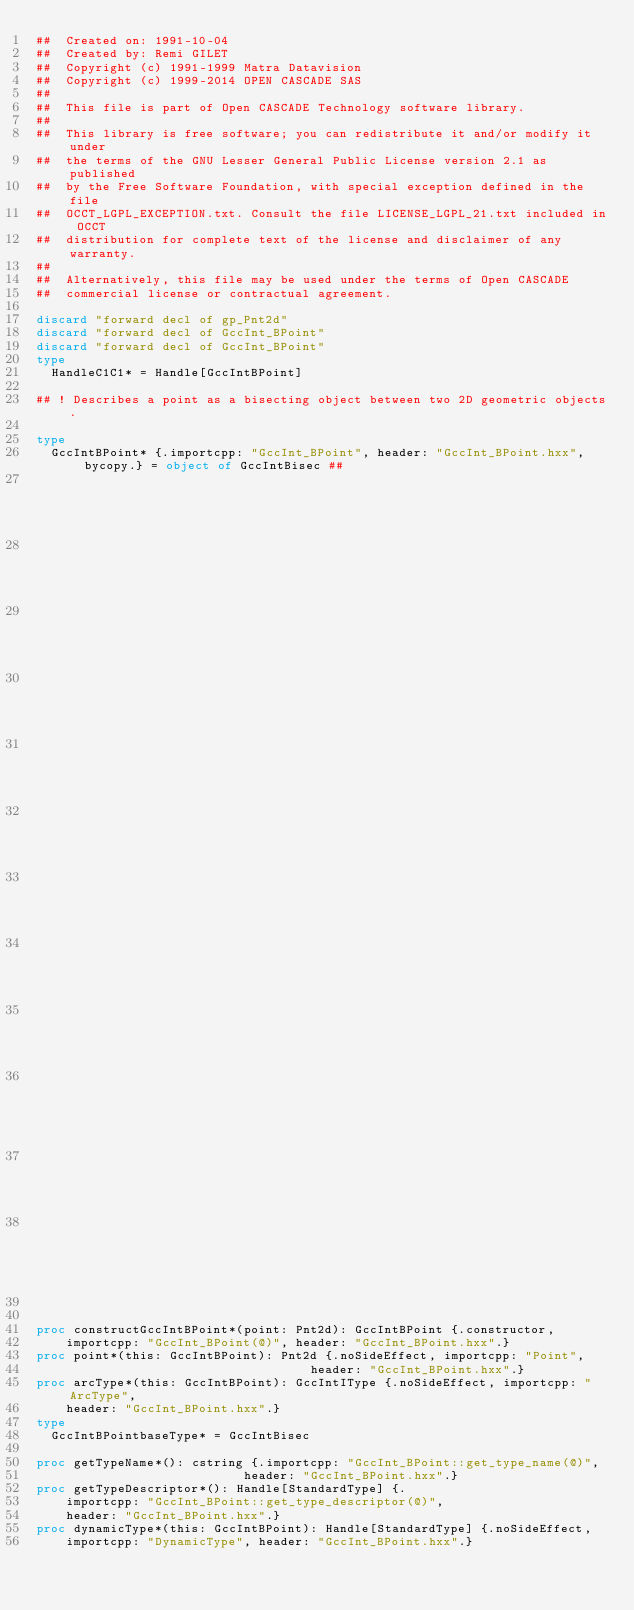Convert code to text. <code><loc_0><loc_0><loc_500><loc_500><_Nim_>##  Created on: 1991-10-04
##  Created by: Remi GILET
##  Copyright (c) 1991-1999 Matra Datavision
##  Copyright (c) 1999-2014 OPEN CASCADE SAS
##
##  This file is part of Open CASCADE Technology software library.
##
##  This library is free software; you can redistribute it and/or modify it under
##  the terms of the GNU Lesser General Public License version 2.1 as published
##  by the Free Software Foundation, with special exception defined in the file
##  OCCT_LGPL_EXCEPTION.txt. Consult the file LICENSE_LGPL_21.txt included in OCCT
##  distribution for complete text of the license and disclaimer of any warranty.
##
##  Alternatively, this file may be used under the terms of Open CASCADE
##  commercial license or contractual agreement.

discard "forward decl of gp_Pnt2d"
discard "forward decl of GccInt_BPoint"
discard "forward decl of GccInt_BPoint"
type
  HandleC1C1* = Handle[GccIntBPoint]

## ! Describes a point as a bisecting object between two 2D geometric objects.

type
  GccIntBPoint* {.importcpp: "GccInt_BPoint", header: "GccInt_BPoint.hxx", bycopy.} = object of GccIntBisec ##
                                                                                                  ## !
                                                                                                  ## Constructs
                                                                                                  ## a
                                                                                                  ## bisecting
                                                                                                  ## object
                                                                                                  ## whose
                                                                                                  ## geometry
                                                                                                  ## is
                                                                                                  ## the
                                                                                                  ## 2D
                                                                                                  ## point
                                                                                                  ## Point.


proc constructGccIntBPoint*(point: Pnt2d): GccIntBPoint {.constructor,
    importcpp: "GccInt_BPoint(@)", header: "GccInt_BPoint.hxx".}
proc point*(this: GccIntBPoint): Pnt2d {.noSideEffect, importcpp: "Point",
                                     header: "GccInt_BPoint.hxx".}
proc arcType*(this: GccIntBPoint): GccIntIType {.noSideEffect, importcpp: "ArcType",
    header: "GccInt_BPoint.hxx".}
type
  GccIntBPointbaseType* = GccIntBisec

proc getTypeName*(): cstring {.importcpp: "GccInt_BPoint::get_type_name(@)",
                            header: "GccInt_BPoint.hxx".}
proc getTypeDescriptor*(): Handle[StandardType] {.
    importcpp: "GccInt_BPoint::get_type_descriptor(@)",
    header: "GccInt_BPoint.hxx".}
proc dynamicType*(this: GccIntBPoint): Handle[StandardType] {.noSideEffect,
    importcpp: "DynamicType", header: "GccInt_BPoint.hxx".}

























</code> 